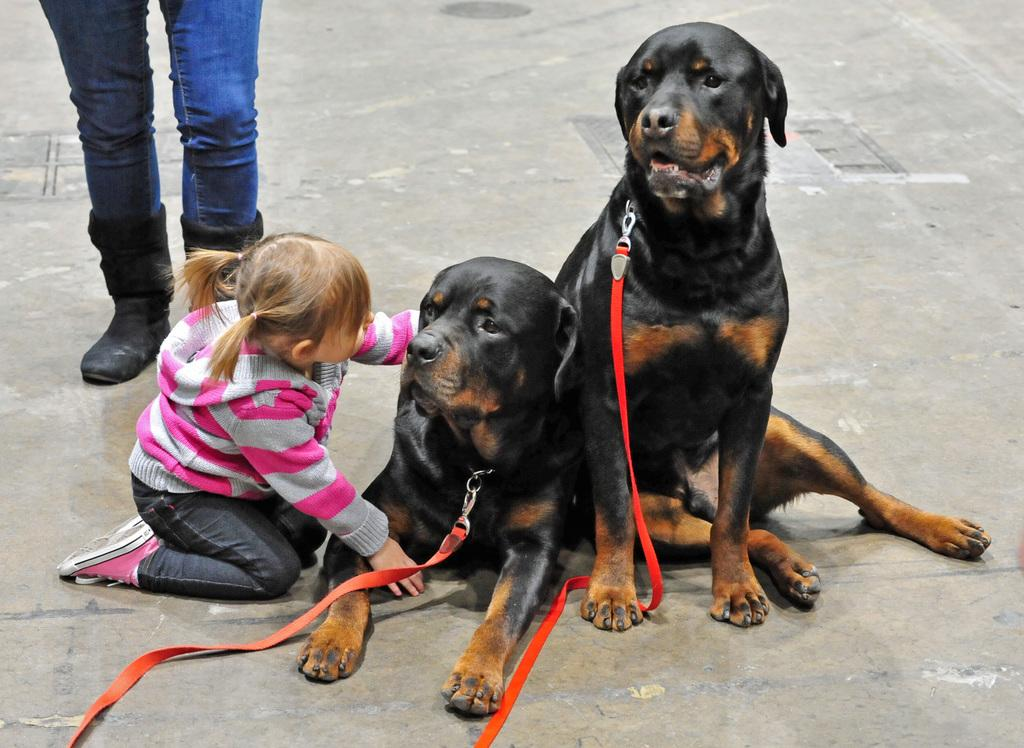How many dogs are in the image? There are two dogs in the image. What color are the dogs? The dogs are black in color. What is the relationship between the kid and the dogs? A kid is sitting beside one of the dogs. What is the woman in the image wearing? The woman is wearing boots. How many sticks are being carried by the geese in the image? There are no geese present in the image, so there are no sticks being carried by them. 